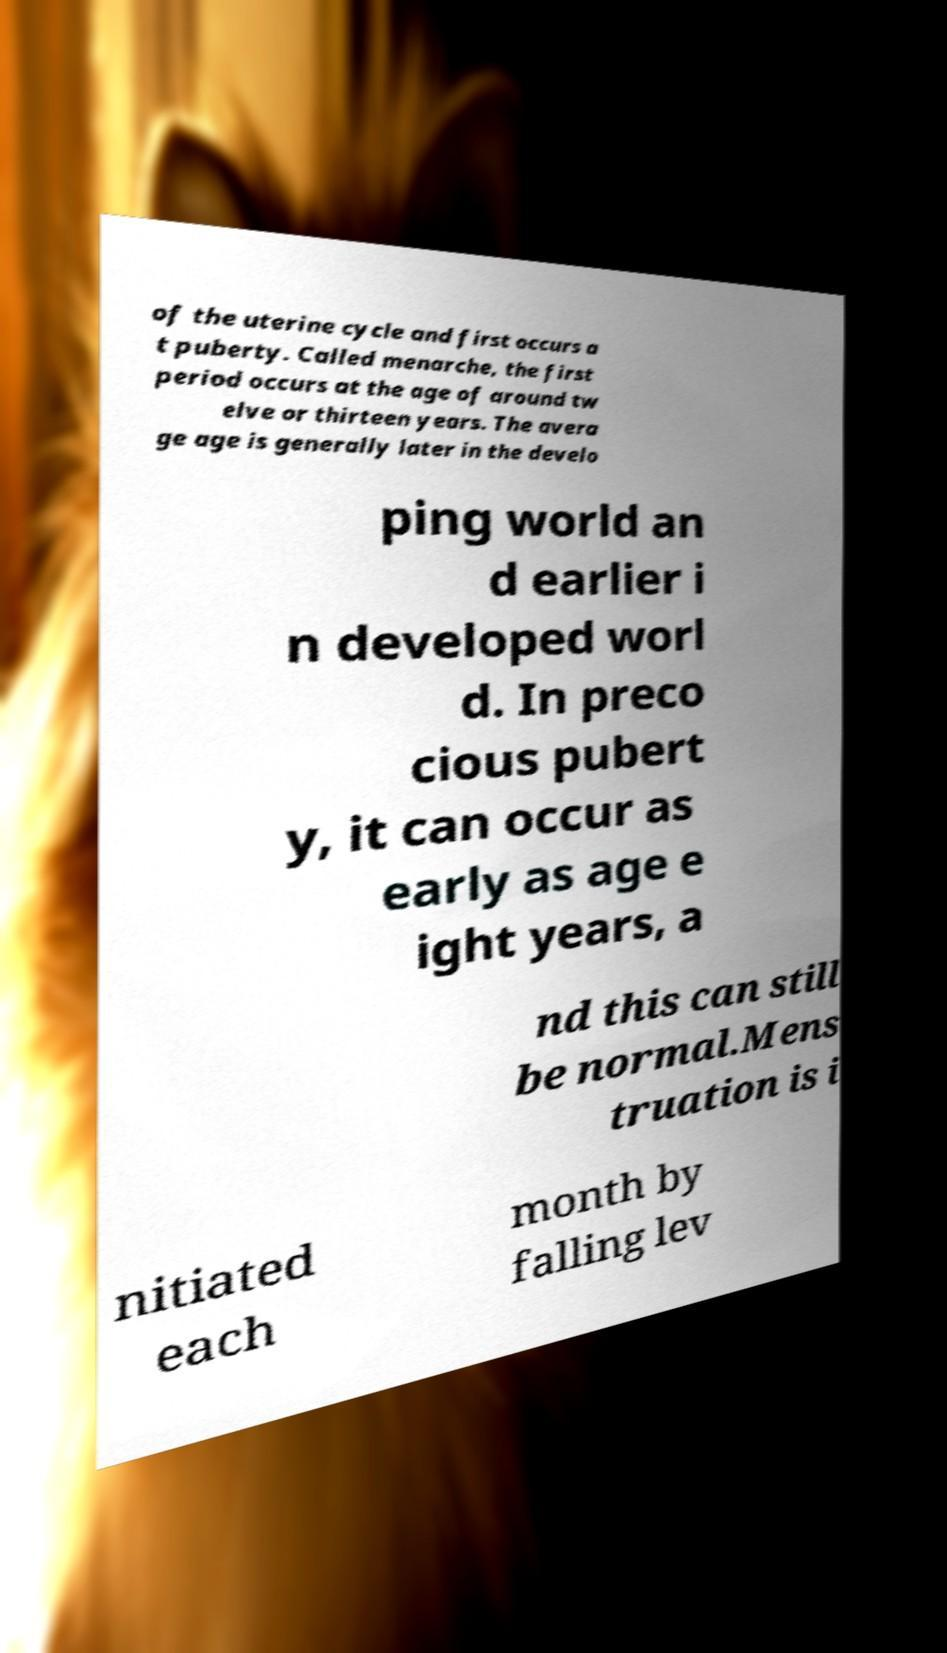Please read and relay the text visible in this image. What does it say? of the uterine cycle and first occurs a t puberty. Called menarche, the first period occurs at the age of around tw elve or thirteen years. The avera ge age is generally later in the develo ping world an d earlier i n developed worl d. In preco cious pubert y, it can occur as early as age e ight years, a nd this can still be normal.Mens truation is i nitiated each month by falling lev 